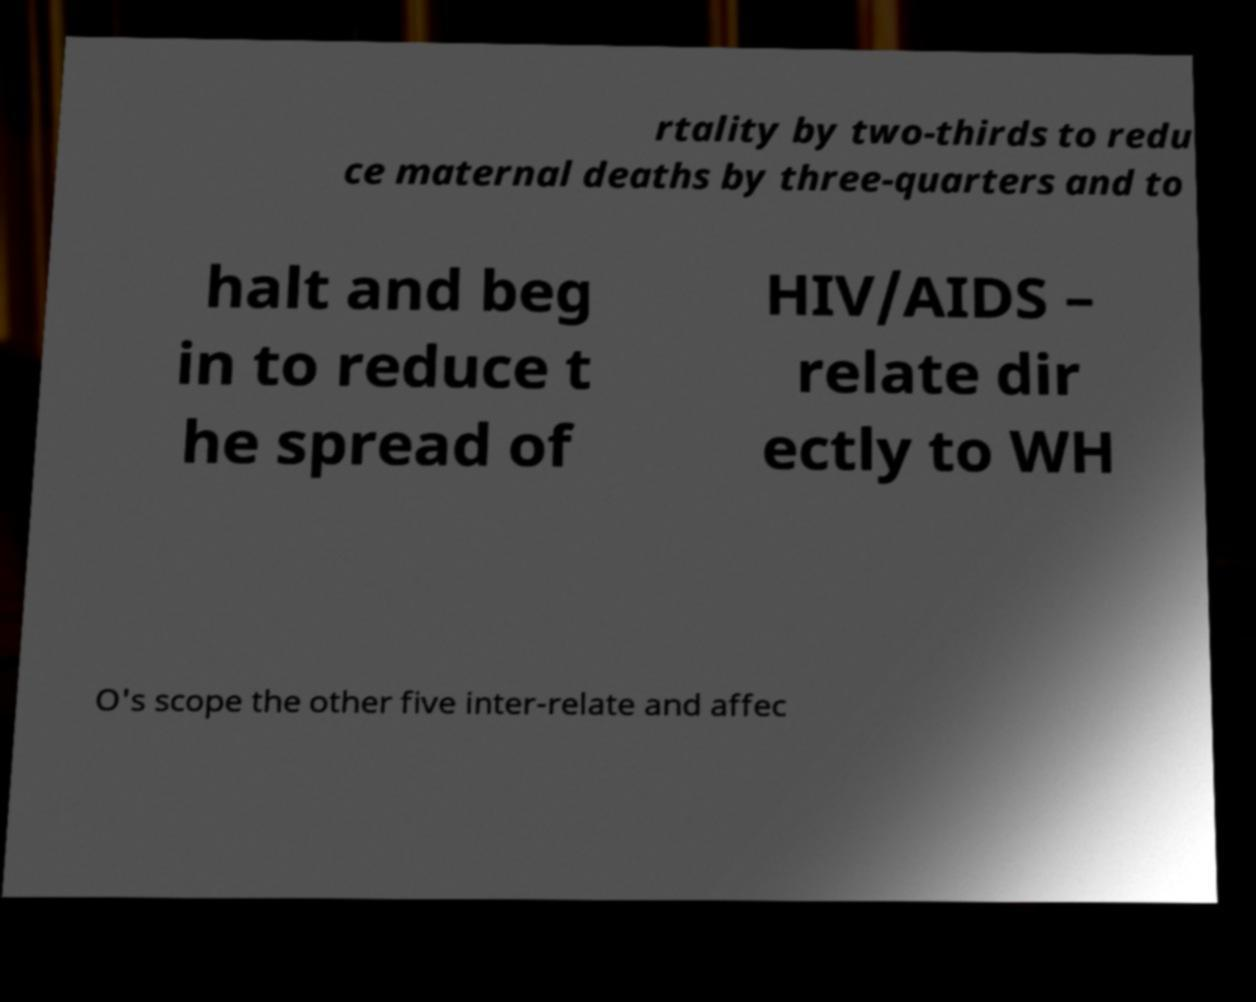Please identify and transcribe the text found in this image. rtality by two-thirds to redu ce maternal deaths by three-quarters and to halt and beg in to reduce t he spread of HIV/AIDS – relate dir ectly to WH O's scope the other five inter-relate and affec 